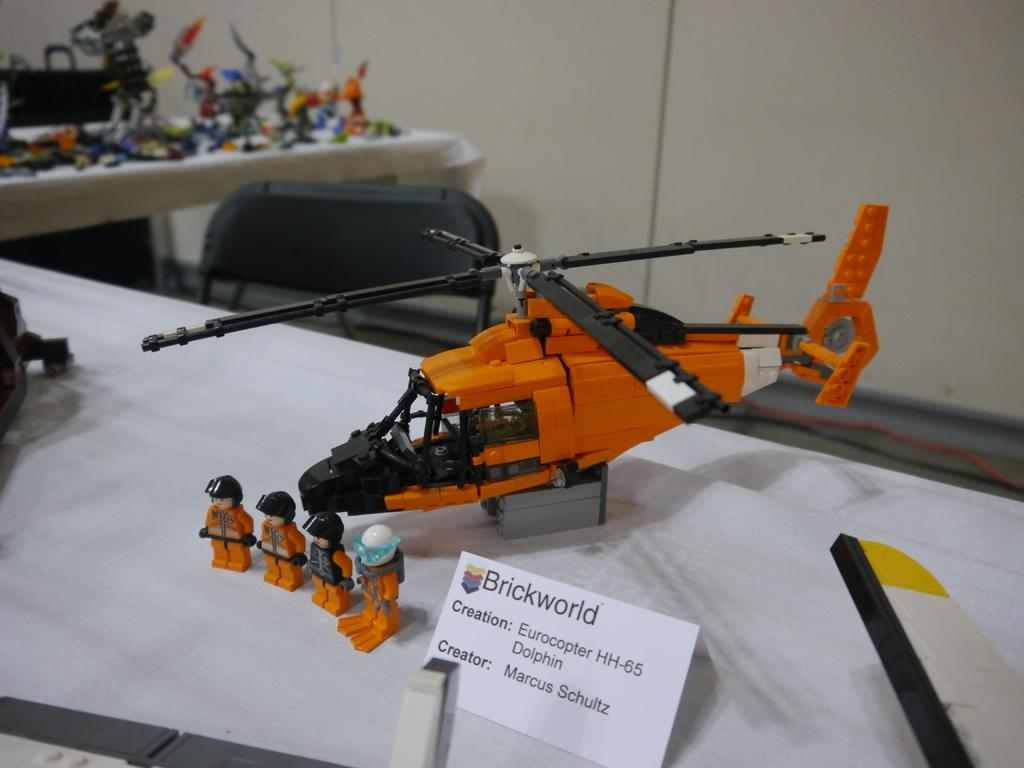<image>
Offer a succinct explanation of the picture presented. Brickworld Eurocopter HH-65 Dolphin created from Legos with 4 lego characters with helmets, and one with swim fins on feet. 